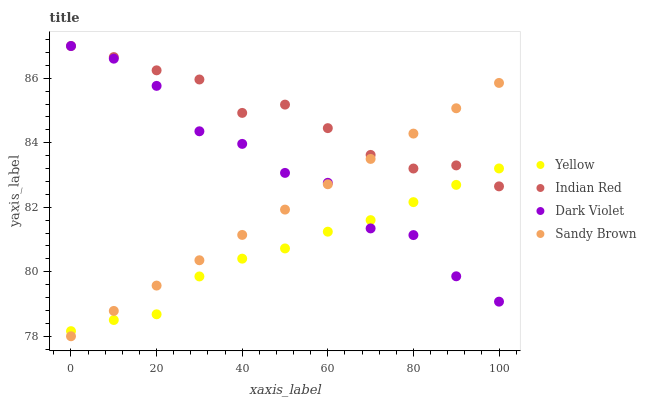Does Yellow have the minimum area under the curve?
Answer yes or no. Yes. Does Indian Red have the maximum area under the curve?
Answer yes or no. Yes. Does Sandy Brown have the minimum area under the curve?
Answer yes or no. No. Does Sandy Brown have the maximum area under the curve?
Answer yes or no. No. Is Sandy Brown the smoothest?
Answer yes or no. Yes. Is Dark Violet the roughest?
Answer yes or no. Yes. Is Indian Red the smoothest?
Answer yes or no. No. Is Indian Red the roughest?
Answer yes or no. No. Does Sandy Brown have the lowest value?
Answer yes or no. Yes. Does Indian Red have the lowest value?
Answer yes or no. No. Does Indian Red have the highest value?
Answer yes or no. Yes. Does Sandy Brown have the highest value?
Answer yes or no. No. Does Indian Red intersect Sandy Brown?
Answer yes or no. Yes. Is Indian Red less than Sandy Brown?
Answer yes or no. No. Is Indian Red greater than Sandy Brown?
Answer yes or no. No. 